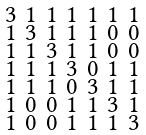Convert formula to latex. <formula><loc_0><loc_0><loc_500><loc_500>\begin{smallmatrix} 3 & 1 & 1 & 1 & 1 & 1 & 1 \\ 1 & 3 & 1 & 1 & 1 & 0 & 0 \\ 1 & 1 & 3 & 1 & 1 & 0 & 0 \\ 1 & 1 & 1 & 3 & 0 & 1 & 1 \\ 1 & 1 & 1 & 0 & 3 & 1 & 1 \\ 1 & 0 & 0 & 1 & 1 & 3 & 1 \\ 1 & 0 & 0 & 1 & 1 & 1 & 3 \end{smallmatrix}</formula> 